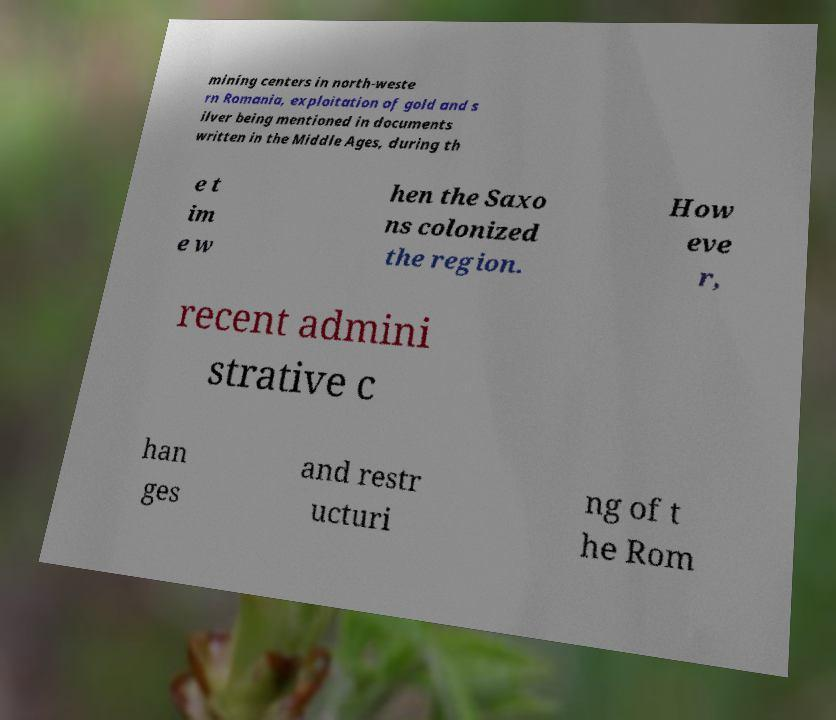There's text embedded in this image that I need extracted. Can you transcribe it verbatim? mining centers in north-weste rn Romania, exploitation of gold and s ilver being mentioned in documents written in the Middle Ages, during th e t im e w hen the Saxo ns colonized the region. How eve r, recent admini strative c han ges and restr ucturi ng of t he Rom 